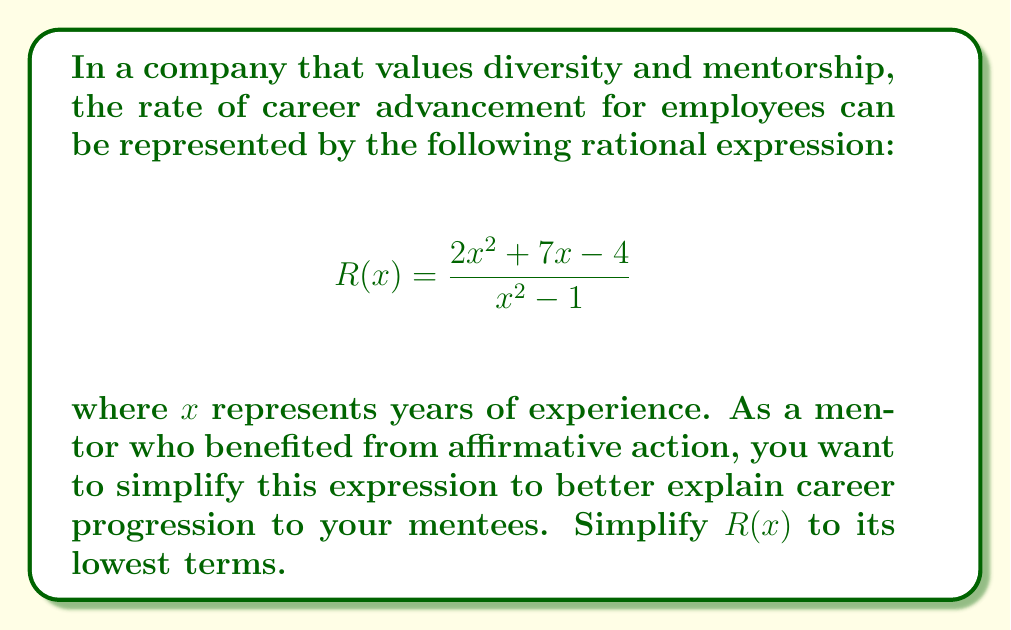Can you answer this question? Let's simplify this rational expression step-by-step:

1) First, we need to factor both the numerator and denominator:

   Numerator: $2x^2 + 7x - 4$
   This is a quadratic expression. We can factor it using the ac-method:
   $2x^2 + 7x - 4 = (2x - 1)(x + 4)$

   Denominator: $x^2 - 1$
   This is a difference of squares:
   $x^2 - 1 = (x+1)(x-1)$

2) Now our expression looks like this:

   $$R(x) = \frac{(2x - 1)(x + 4)}{(x+1)(x-1)}$$

3) We can see that there are no common factors between the numerator and denominator, so this is the simplest form of the rational expression.

4) However, we can note that this expression is undefined when $x = 1$ or $x = -1$, as these values would make the denominator zero.
Answer: $$R(x) = \frac{(2x - 1)(x + 4)}{(x+1)(x-1)}, x \neq \pm 1$$ 